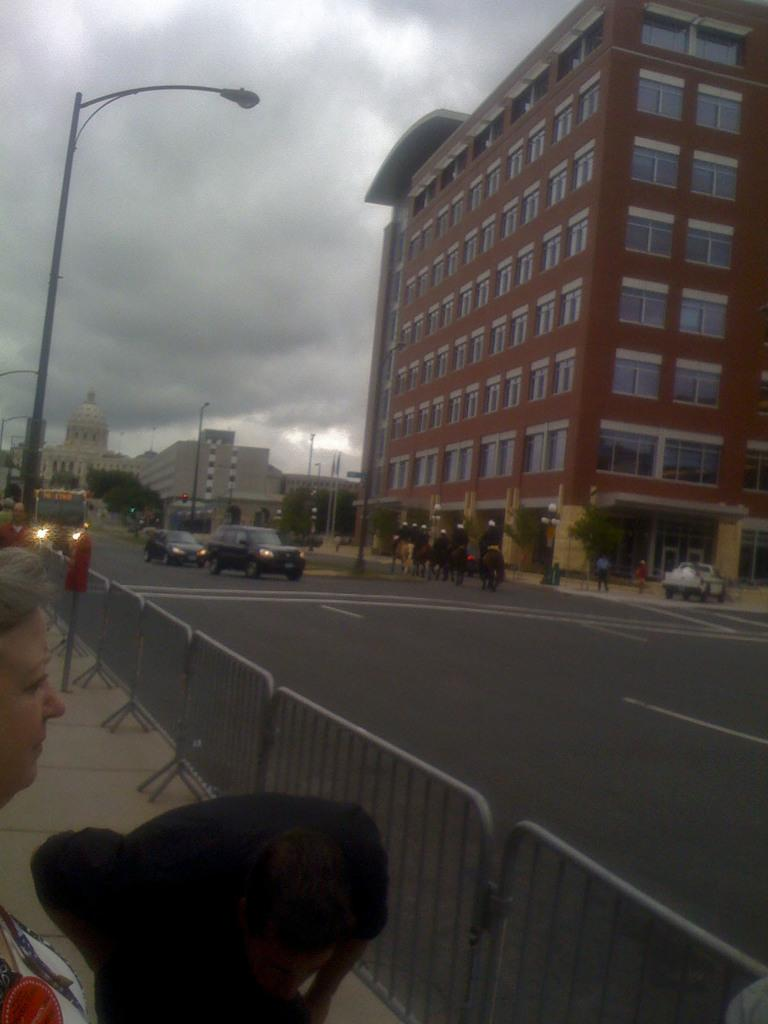What is happening at the bottom of the image? There are persons near the barricades at the bottom of the image. What can be seen in the distance in the image? There are buildings, vehicles, poles, people, animals, and the sky visible in the background of the image. Can you tell me where the aunt is located in the image? There is no aunt present in the image. What type of prison can be seen in the background of the image? There is no prison present in the image. 